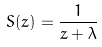<formula> <loc_0><loc_0><loc_500><loc_500>S ( z ) = \frac { 1 } { z + \lambda }</formula> 